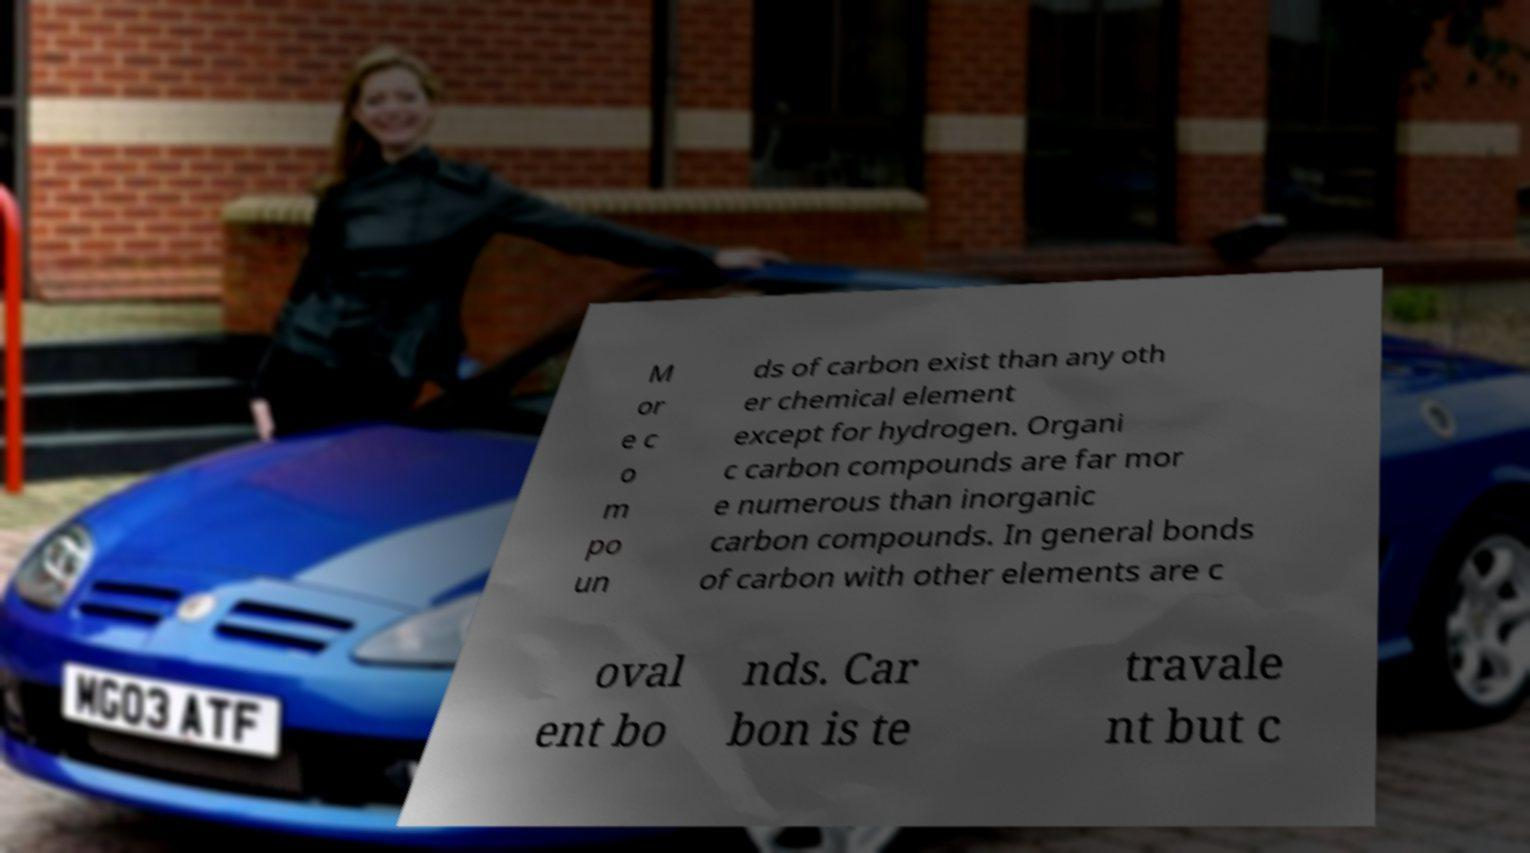Can you accurately transcribe the text from the provided image for me? M or e c o m po un ds of carbon exist than any oth er chemical element except for hydrogen. Organi c carbon compounds are far mor e numerous than inorganic carbon compounds. In general bonds of carbon with other elements are c oval ent bo nds. Car bon is te travale nt but c 